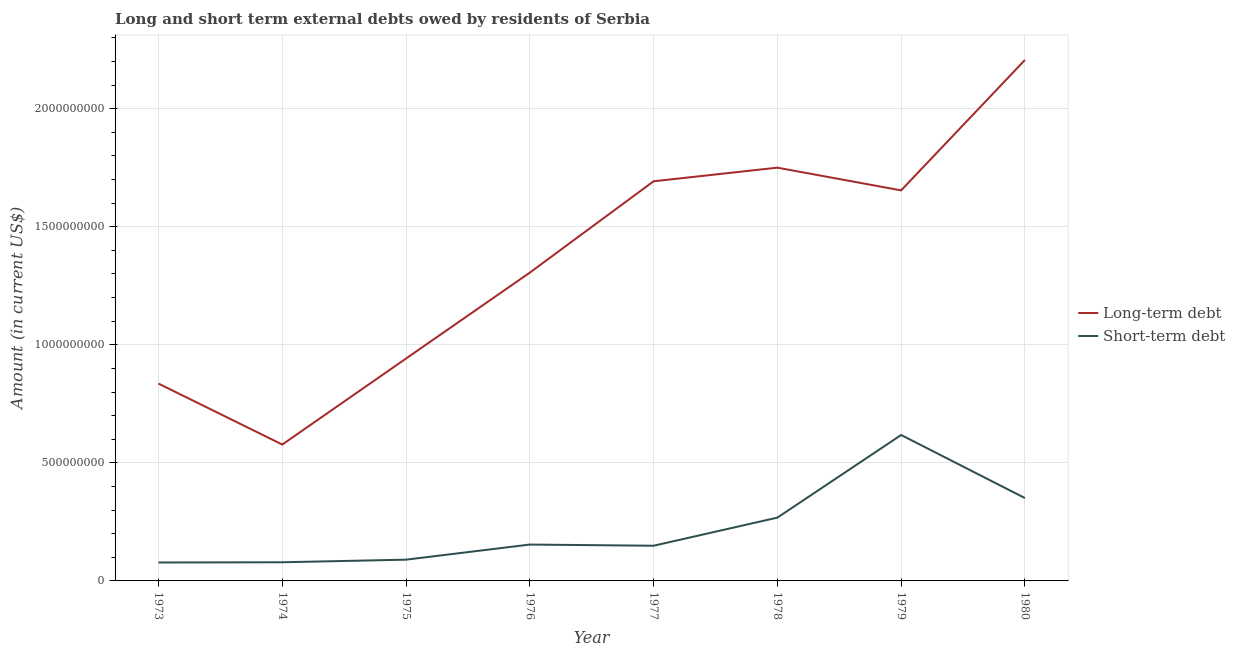Does the line corresponding to long-term debts owed by residents intersect with the line corresponding to short-term debts owed by residents?
Your answer should be very brief. No. What is the long-term debts owed by residents in 1979?
Keep it short and to the point. 1.65e+09. Across all years, what is the maximum short-term debts owed by residents?
Provide a short and direct response. 6.18e+08. Across all years, what is the minimum long-term debts owed by residents?
Offer a very short reply. 5.78e+08. What is the total short-term debts owed by residents in the graph?
Keep it short and to the point. 1.79e+09. What is the difference between the short-term debts owed by residents in 1974 and that in 1980?
Keep it short and to the point. -2.72e+08. What is the difference between the long-term debts owed by residents in 1980 and the short-term debts owed by residents in 1975?
Your answer should be very brief. 2.12e+09. What is the average short-term debts owed by residents per year?
Keep it short and to the point. 2.23e+08. In the year 1974, what is the difference between the short-term debts owed by residents and long-term debts owed by residents?
Your answer should be very brief. -4.99e+08. In how many years, is the long-term debts owed by residents greater than 1400000000 US$?
Your response must be concise. 4. What is the ratio of the short-term debts owed by residents in 1973 to that in 1979?
Make the answer very short. 0.13. What is the difference between the highest and the second highest long-term debts owed by residents?
Provide a succinct answer. 4.56e+08. What is the difference between the highest and the lowest long-term debts owed by residents?
Make the answer very short. 1.63e+09. Is the sum of the short-term debts owed by residents in 1976 and 1980 greater than the maximum long-term debts owed by residents across all years?
Ensure brevity in your answer.  No. Is the short-term debts owed by residents strictly less than the long-term debts owed by residents over the years?
Your answer should be compact. Yes. How many lines are there?
Ensure brevity in your answer.  2. Are the values on the major ticks of Y-axis written in scientific E-notation?
Offer a terse response. No. Where does the legend appear in the graph?
Your answer should be very brief. Center right. How are the legend labels stacked?
Ensure brevity in your answer.  Vertical. What is the title of the graph?
Make the answer very short. Long and short term external debts owed by residents of Serbia. What is the label or title of the X-axis?
Provide a short and direct response. Year. What is the label or title of the Y-axis?
Offer a very short reply. Amount (in current US$). What is the Amount (in current US$) of Long-term debt in 1973?
Keep it short and to the point. 8.36e+08. What is the Amount (in current US$) in Short-term debt in 1973?
Give a very brief answer. 7.80e+07. What is the Amount (in current US$) of Long-term debt in 1974?
Offer a terse response. 5.78e+08. What is the Amount (in current US$) of Short-term debt in 1974?
Provide a succinct answer. 7.90e+07. What is the Amount (in current US$) in Long-term debt in 1975?
Provide a short and direct response. 9.42e+08. What is the Amount (in current US$) in Short-term debt in 1975?
Make the answer very short. 9.00e+07. What is the Amount (in current US$) of Long-term debt in 1976?
Your answer should be very brief. 1.31e+09. What is the Amount (in current US$) of Short-term debt in 1976?
Provide a short and direct response. 1.54e+08. What is the Amount (in current US$) of Long-term debt in 1977?
Your answer should be compact. 1.69e+09. What is the Amount (in current US$) of Short-term debt in 1977?
Make the answer very short. 1.49e+08. What is the Amount (in current US$) of Long-term debt in 1978?
Offer a very short reply. 1.75e+09. What is the Amount (in current US$) of Short-term debt in 1978?
Provide a short and direct response. 2.68e+08. What is the Amount (in current US$) in Long-term debt in 1979?
Ensure brevity in your answer.  1.65e+09. What is the Amount (in current US$) in Short-term debt in 1979?
Make the answer very short. 6.18e+08. What is the Amount (in current US$) of Long-term debt in 1980?
Offer a very short reply. 2.21e+09. What is the Amount (in current US$) in Short-term debt in 1980?
Provide a short and direct response. 3.51e+08. Across all years, what is the maximum Amount (in current US$) of Long-term debt?
Make the answer very short. 2.21e+09. Across all years, what is the maximum Amount (in current US$) in Short-term debt?
Ensure brevity in your answer.  6.18e+08. Across all years, what is the minimum Amount (in current US$) of Long-term debt?
Provide a succinct answer. 5.78e+08. Across all years, what is the minimum Amount (in current US$) in Short-term debt?
Offer a very short reply. 7.80e+07. What is the total Amount (in current US$) of Long-term debt in the graph?
Your answer should be compact. 1.10e+1. What is the total Amount (in current US$) of Short-term debt in the graph?
Offer a very short reply. 1.79e+09. What is the difference between the Amount (in current US$) of Long-term debt in 1973 and that in 1974?
Provide a short and direct response. 2.58e+08. What is the difference between the Amount (in current US$) of Long-term debt in 1973 and that in 1975?
Keep it short and to the point. -1.06e+08. What is the difference between the Amount (in current US$) in Short-term debt in 1973 and that in 1975?
Your answer should be very brief. -1.20e+07. What is the difference between the Amount (in current US$) in Long-term debt in 1973 and that in 1976?
Provide a succinct answer. -4.70e+08. What is the difference between the Amount (in current US$) of Short-term debt in 1973 and that in 1976?
Your answer should be very brief. -7.60e+07. What is the difference between the Amount (in current US$) in Long-term debt in 1973 and that in 1977?
Provide a succinct answer. -8.57e+08. What is the difference between the Amount (in current US$) of Short-term debt in 1973 and that in 1977?
Make the answer very short. -7.10e+07. What is the difference between the Amount (in current US$) of Long-term debt in 1973 and that in 1978?
Ensure brevity in your answer.  -9.14e+08. What is the difference between the Amount (in current US$) of Short-term debt in 1973 and that in 1978?
Offer a terse response. -1.90e+08. What is the difference between the Amount (in current US$) in Long-term debt in 1973 and that in 1979?
Make the answer very short. -8.18e+08. What is the difference between the Amount (in current US$) in Short-term debt in 1973 and that in 1979?
Offer a very short reply. -5.40e+08. What is the difference between the Amount (in current US$) of Long-term debt in 1973 and that in 1980?
Keep it short and to the point. -1.37e+09. What is the difference between the Amount (in current US$) in Short-term debt in 1973 and that in 1980?
Offer a very short reply. -2.73e+08. What is the difference between the Amount (in current US$) of Long-term debt in 1974 and that in 1975?
Ensure brevity in your answer.  -3.64e+08. What is the difference between the Amount (in current US$) in Short-term debt in 1974 and that in 1975?
Your response must be concise. -1.10e+07. What is the difference between the Amount (in current US$) in Long-term debt in 1974 and that in 1976?
Your response must be concise. -7.28e+08. What is the difference between the Amount (in current US$) in Short-term debt in 1974 and that in 1976?
Provide a succinct answer. -7.50e+07. What is the difference between the Amount (in current US$) of Long-term debt in 1974 and that in 1977?
Provide a succinct answer. -1.11e+09. What is the difference between the Amount (in current US$) in Short-term debt in 1974 and that in 1977?
Offer a very short reply. -7.00e+07. What is the difference between the Amount (in current US$) of Long-term debt in 1974 and that in 1978?
Your answer should be very brief. -1.17e+09. What is the difference between the Amount (in current US$) of Short-term debt in 1974 and that in 1978?
Offer a terse response. -1.89e+08. What is the difference between the Amount (in current US$) in Long-term debt in 1974 and that in 1979?
Your answer should be compact. -1.08e+09. What is the difference between the Amount (in current US$) in Short-term debt in 1974 and that in 1979?
Your answer should be very brief. -5.39e+08. What is the difference between the Amount (in current US$) of Long-term debt in 1974 and that in 1980?
Make the answer very short. -1.63e+09. What is the difference between the Amount (in current US$) in Short-term debt in 1974 and that in 1980?
Offer a very short reply. -2.72e+08. What is the difference between the Amount (in current US$) of Long-term debt in 1975 and that in 1976?
Keep it short and to the point. -3.64e+08. What is the difference between the Amount (in current US$) of Short-term debt in 1975 and that in 1976?
Offer a terse response. -6.40e+07. What is the difference between the Amount (in current US$) of Long-term debt in 1975 and that in 1977?
Offer a very short reply. -7.51e+08. What is the difference between the Amount (in current US$) in Short-term debt in 1975 and that in 1977?
Provide a short and direct response. -5.90e+07. What is the difference between the Amount (in current US$) of Long-term debt in 1975 and that in 1978?
Provide a short and direct response. -8.08e+08. What is the difference between the Amount (in current US$) in Short-term debt in 1975 and that in 1978?
Provide a succinct answer. -1.78e+08. What is the difference between the Amount (in current US$) of Long-term debt in 1975 and that in 1979?
Your answer should be very brief. -7.12e+08. What is the difference between the Amount (in current US$) of Short-term debt in 1975 and that in 1979?
Offer a very short reply. -5.28e+08. What is the difference between the Amount (in current US$) of Long-term debt in 1975 and that in 1980?
Ensure brevity in your answer.  -1.26e+09. What is the difference between the Amount (in current US$) in Short-term debt in 1975 and that in 1980?
Your response must be concise. -2.61e+08. What is the difference between the Amount (in current US$) in Long-term debt in 1976 and that in 1977?
Your answer should be very brief. -3.87e+08. What is the difference between the Amount (in current US$) of Short-term debt in 1976 and that in 1977?
Offer a terse response. 5.00e+06. What is the difference between the Amount (in current US$) of Long-term debt in 1976 and that in 1978?
Give a very brief answer. -4.45e+08. What is the difference between the Amount (in current US$) of Short-term debt in 1976 and that in 1978?
Offer a terse response. -1.14e+08. What is the difference between the Amount (in current US$) of Long-term debt in 1976 and that in 1979?
Your answer should be compact. -3.48e+08. What is the difference between the Amount (in current US$) of Short-term debt in 1976 and that in 1979?
Make the answer very short. -4.64e+08. What is the difference between the Amount (in current US$) of Long-term debt in 1976 and that in 1980?
Give a very brief answer. -9.00e+08. What is the difference between the Amount (in current US$) in Short-term debt in 1976 and that in 1980?
Your answer should be compact. -1.97e+08. What is the difference between the Amount (in current US$) of Long-term debt in 1977 and that in 1978?
Provide a short and direct response. -5.77e+07. What is the difference between the Amount (in current US$) of Short-term debt in 1977 and that in 1978?
Give a very brief answer. -1.19e+08. What is the difference between the Amount (in current US$) of Long-term debt in 1977 and that in 1979?
Provide a succinct answer. 3.85e+07. What is the difference between the Amount (in current US$) in Short-term debt in 1977 and that in 1979?
Give a very brief answer. -4.69e+08. What is the difference between the Amount (in current US$) of Long-term debt in 1977 and that in 1980?
Offer a terse response. -5.14e+08. What is the difference between the Amount (in current US$) in Short-term debt in 1977 and that in 1980?
Your answer should be compact. -2.02e+08. What is the difference between the Amount (in current US$) in Long-term debt in 1978 and that in 1979?
Offer a very short reply. 9.62e+07. What is the difference between the Amount (in current US$) in Short-term debt in 1978 and that in 1979?
Offer a very short reply. -3.50e+08. What is the difference between the Amount (in current US$) in Long-term debt in 1978 and that in 1980?
Your answer should be compact. -4.56e+08. What is the difference between the Amount (in current US$) in Short-term debt in 1978 and that in 1980?
Offer a very short reply. -8.30e+07. What is the difference between the Amount (in current US$) of Long-term debt in 1979 and that in 1980?
Your answer should be very brief. -5.52e+08. What is the difference between the Amount (in current US$) in Short-term debt in 1979 and that in 1980?
Your response must be concise. 2.67e+08. What is the difference between the Amount (in current US$) of Long-term debt in 1973 and the Amount (in current US$) of Short-term debt in 1974?
Give a very brief answer. 7.57e+08. What is the difference between the Amount (in current US$) of Long-term debt in 1973 and the Amount (in current US$) of Short-term debt in 1975?
Offer a terse response. 7.46e+08. What is the difference between the Amount (in current US$) in Long-term debt in 1973 and the Amount (in current US$) in Short-term debt in 1976?
Your answer should be very brief. 6.82e+08. What is the difference between the Amount (in current US$) of Long-term debt in 1973 and the Amount (in current US$) of Short-term debt in 1977?
Keep it short and to the point. 6.87e+08. What is the difference between the Amount (in current US$) in Long-term debt in 1973 and the Amount (in current US$) in Short-term debt in 1978?
Your answer should be very brief. 5.68e+08. What is the difference between the Amount (in current US$) in Long-term debt in 1973 and the Amount (in current US$) in Short-term debt in 1979?
Provide a short and direct response. 2.18e+08. What is the difference between the Amount (in current US$) in Long-term debt in 1973 and the Amount (in current US$) in Short-term debt in 1980?
Give a very brief answer. 4.85e+08. What is the difference between the Amount (in current US$) in Long-term debt in 1974 and the Amount (in current US$) in Short-term debt in 1975?
Keep it short and to the point. 4.88e+08. What is the difference between the Amount (in current US$) in Long-term debt in 1974 and the Amount (in current US$) in Short-term debt in 1976?
Keep it short and to the point. 4.24e+08. What is the difference between the Amount (in current US$) of Long-term debt in 1974 and the Amount (in current US$) of Short-term debt in 1977?
Your response must be concise. 4.29e+08. What is the difference between the Amount (in current US$) of Long-term debt in 1974 and the Amount (in current US$) of Short-term debt in 1978?
Your response must be concise. 3.10e+08. What is the difference between the Amount (in current US$) of Long-term debt in 1974 and the Amount (in current US$) of Short-term debt in 1979?
Your answer should be compact. -4.04e+07. What is the difference between the Amount (in current US$) of Long-term debt in 1974 and the Amount (in current US$) of Short-term debt in 1980?
Your answer should be very brief. 2.27e+08. What is the difference between the Amount (in current US$) in Long-term debt in 1975 and the Amount (in current US$) in Short-term debt in 1976?
Ensure brevity in your answer.  7.88e+08. What is the difference between the Amount (in current US$) of Long-term debt in 1975 and the Amount (in current US$) of Short-term debt in 1977?
Make the answer very short. 7.93e+08. What is the difference between the Amount (in current US$) of Long-term debt in 1975 and the Amount (in current US$) of Short-term debt in 1978?
Make the answer very short. 6.74e+08. What is the difference between the Amount (in current US$) in Long-term debt in 1975 and the Amount (in current US$) in Short-term debt in 1979?
Provide a short and direct response. 3.24e+08. What is the difference between the Amount (in current US$) of Long-term debt in 1975 and the Amount (in current US$) of Short-term debt in 1980?
Your response must be concise. 5.91e+08. What is the difference between the Amount (in current US$) in Long-term debt in 1976 and the Amount (in current US$) in Short-term debt in 1977?
Provide a succinct answer. 1.16e+09. What is the difference between the Amount (in current US$) of Long-term debt in 1976 and the Amount (in current US$) of Short-term debt in 1978?
Ensure brevity in your answer.  1.04e+09. What is the difference between the Amount (in current US$) in Long-term debt in 1976 and the Amount (in current US$) in Short-term debt in 1979?
Make the answer very short. 6.88e+08. What is the difference between the Amount (in current US$) of Long-term debt in 1976 and the Amount (in current US$) of Short-term debt in 1980?
Keep it short and to the point. 9.55e+08. What is the difference between the Amount (in current US$) in Long-term debt in 1977 and the Amount (in current US$) in Short-term debt in 1978?
Make the answer very short. 1.42e+09. What is the difference between the Amount (in current US$) in Long-term debt in 1977 and the Amount (in current US$) in Short-term debt in 1979?
Your answer should be compact. 1.07e+09. What is the difference between the Amount (in current US$) in Long-term debt in 1977 and the Amount (in current US$) in Short-term debt in 1980?
Your answer should be compact. 1.34e+09. What is the difference between the Amount (in current US$) of Long-term debt in 1978 and the Amount (in current US$) of Short-term debt in 1979?
Make the answer very short. 1.13e+09. What is the difference between the Amount (in current US$) of Long-term debt in 1978 and the Amount (in current US$) of Short-term debt in 1980?
Make the answer very short. 1.40e+09. What is the difference between the Amount (in current US$) in Long-term debt in 1979 and the Amount (in current US$) in Short-term debt in 1980?
Keep it short and to the point. 1.30e+09. What is the average Amount (in current US$) in Long-term debt per year?
Offer a terse response. 1.37e+09. What is the average Amount (in current US$) of Short-term debt per year?
Give a very brief answer. 2.23e+08. In the year 1973, what is the difference between the Amount (in current US$) in Long-term debt and Amount (in current US$) in Short-term debt?
Offer a very short reply. 7.58e+08. In the year 1974, what is the difference between the Amount (in current US$) in Long-term debt and Amount (in current US$) in Short-term debt?
Provide a short and direct response. 4.99e+08. In the year 1975, what is the difference between the Amount (in current US$) of Long-term debt and Amount (in current US$) of Short-term debt?
Your answer should be compact. 8.52e+08. In the year 1976, what is the difference between the Amount (in current US$) of Long-term debt and Amount (in current US$) of Short-term debt?
Your response must be concise. 1.15e+09. In the year 1977, what is the difference between the Amount (in current US$) in Long-term debt and Amount (in current US$) in Short-term debt?
Ensure brevity in your answer.  1.54e+09. In the year 1978, what is the difference between the Amount (in current US$) of Long-term debt and Amount (in current US$) of Short-term debt?
Your answer should be compact. 1.48e+09. In the year 1979, what is the difference between the Amount (in current US$) in Long-term debt and Amount (in current US$) in Short-term debt?
Your answer should be compact. 1.04e+09. In the year 1980, what is the difference between the Amount (in current US$) in Long-term debt and Amount (in current US$) in Short-term debt?
Provide a succinct answer. 1.86e+09. What is the ratio of the Amount (in current US$) of Long-term debt in 1973 to that in 1974?
Make the answer very short. 1.45. What is the ratio of the Amount (in current US$) of Short-term debt in 1973 to that in 1974?
Make the answer very short. 0.99. What is the ratio of the Amount (in current US$) of Long-term debt in 1973 to that in 1975?
Offer a terse response. 0.89. What is the ratio of the Amount (in current US$) of Short-term debt in 1973 to that in 1975?
Your response must be concise. 0.87. What is the ratio of the Amount (in current US$) of Long-term debt in 1973 to that in 1976?
Your answer should be very brief. 0.64. What is the ratio of the Amount (in current US$) of Short-term debt in 1973 to that in 1976?
Offer a very short reply. 0.51. What is the ratio of the Amount (in current US$) of Long-term debt in 1973 to that in 1977?
Give a very brief answer. 0.49. What is the ratio of the Amount (in current US$) in Short-term debt in 1973 to that in 1977?
Your answer should be compact. 0.52. What is the ratio of the Amount (in current US$) of Long-term debt in 1973 to that in 1978?
Keep it short and to the point. 0.48. What is the ratio of the Amount (in current US$) of Short-term debt in 1973 to that in 1978?
Offer a very short reply. 0.29. What is the ratio of the Amount (in current US$) in Long-term debt in 1973 to that in 1979?
Provide a succinct answer. 0.51. What is the ratio of the Amount (in current US$) in Short-term debt in 1973 to that in 1979?
Provide a succinct answer. 0.13. What is the ratio of the Amount (in current US$) in Long-term debt in 1973 to that in 1980?
Provide a succinct answer. 0.38. What is the ratio of the Amount (in current US$) in Short-term debt in 1973 to that in 1980?
Give a very brief answer. 0.22. What is the ratio of the Amount (in current US$) of Long-term debt in 1974 to that in 1975?
Your answer should be very brief. 0.61. What is the ratio of the Amount (in current US$) in Short-term debt in 1974 to that in 1975?
Provide a short and direct response. 0.88. What is the ratio of the Amount (in current US$) of Long-term debt in 1974 to that in 1976?
Give a very brief answer. 0.44. What is the ratio of the Amount (in current US$) in Short-term debt in 1974 to that in 1976?
Your response must be concise. 0.51. What is the ratio of the Amount (in current US$) of Long-term debt in 1974 to that in 1977?
Make the answer very short. 0.34. What is the ratio of the Amount (in current US$) in Short-term debt in 1974 to that in 1977?
Offer a very short reply. 0.53. What is the ratio of the Amount (in current US$) of Long-term debt in 1974 to that in 1978?
Offer a terse response. 0.33. What is the ratio of the Amount (in current US$) in Short-term debt in 1974 to that in 1978?
Make the answer very short. 0.29. What is the ratio of the Amount (in current US$) of Long-term debt in 1974 to that in 1979?
Give a very brief answer. 0.35. What is the ratio of the Amount (in current US$) of Short-term debt in 1974 to that in 1979?
Make the answer very short. 0.13. What is the ratio of the Amount (in current US$) of Long-term debt in 1974 to that in 1980?
Offer a terse response. 0.26. What is the ratio of the Amount (in current US$) of Short-term debt in 1974 to that in 1980?
Give a very brief answer. 0.23. What is the ratio of the Amount (in current US$) in Long-term debt in 1975 to that in 1976?
Offer a terse response. 0.72. What is the ratio of the Amount (in current US$) of Short-term debt in 1975 to that in 1976?
Offer a very short reply. 0.58. What is the ratio of the Amount (in current US$) of Long-term debt in 1975 to that in 1977?
Make the answer very short. 0.56. What is the ratio of the Amount (in current US$) in Short-term debt in 1975 to that in 1977?
Provide a short and direct response. 0.6. What is the ratio of the Amount (in current US$) in Long-term debt in 1975 to that in 1978?
Your response must be concise. 0.54. What is the ratio of the Amount (in current US$) of Short-term debt in 1975 to that in 1978?
Your response must be concise. 0.34. What is the ratio of the Amount (in current US$) in Long-term debt in 1975 to that in 1979?
Ensure brevity in your answer.  0.57. What is the ratio of the Amount (in current US$) of Short-term debt in 1975 to that in 1979?
Give a very brief answer. 0.15. What is the ratio of the Amount (in current US$) of Long-term debt in 1975 to that in 1980?
Your response must be concise. 0.43. What is the ratio of the Amount (in current US$) of Short-term debt in 1975 to that in 1980?
Provide a succinct answer. 0.26. What is the ratio of the Amount (in current US$) in Long-term debt in 1976 to that in 1977?
Make the answer very short. 0.77. What is the ratio of the Amount (in current US$) of Short-term debt in 1976 to that in 1977?
Offer a terse response. 1.03. What is the ratio of the Amount (in current US$) in Long-term debt in 1976 to that in 1978?
Give a very brief answer. 0.75. What is the ratio of the Amount (in current US$) of Short-term debt in 1976 to that in 1978?
Ensure brevity in your answer.  0.57. What is the ratio of the Amount (in current US$) in Long-term debt in 1976 to that in 1979?
Your answer should be very brief. 0.79. What is the ratio of the Amount (in current US$) in Short-term debt in 1976 to that in 1979?
Your answer should be compact. 0.25. What is the ratio of the Amount (in current US$) of Long-term debt in 1976 to that in 1980?
Your response must be concise. 0.59. What is the ratio of the Amount (in current US$) of Short-term debt in 1976 to that in 1980?
Offer a very short reply. 0.44. What is the ratio of the Amount (in current US$) of Long-term debt in 1977 to that in 1978?
Your answer should be very brief. 0.97. What is the ratio of the Amount (in current US$) in Short-term debt in 1977 to that in 1978?
Give a very brief answer. 0.56. What is the ratio of the Amount (in current US$) in Long-term debt in 1977 to that in 1979?
Provide a short and direct response. 1.02. What is the ratio of the Amount (in current US$) in Short-term debt in 1977 to that in 1979?
Your response must be concise. 0.24. What is the ratio of the Amount (in current US$) of Long-term debt in 1977 to that in 1980?
Make the answer very short. 0.77. What is the ratio of the Amount (in current US$) in Short-term debt in 1977 to that in 1980?
Ensure brevity in your answer.  0.42. What is the ratio of the Amount (in current US$) in Long-term debt in 1978 to that in 1979?
Your answer should be very brief. 1.06. What is the ratio of the Amount (in current US$) in Short-term debt in 1978 to that in 1979?
Make the answer very short. 0.43. What is the ratio of the Amount (in current US$) of Long-term debt in 1978 to that in 1980?
Ensure brevity in your answer.  0.79. What is the ratio of the Amount (in current US$) in Short-term debt in 1978 to that in 1980?
Give a very brief answer. 0.76. What is the ratio of the Amount (in current US$) in Long-term debt in 1979 to that in 1980?
Make the answer very short. 0.75. What is the ratio of the Amount (in current US$) of Short-term debt in 1979 to that in 1980?
Make the answer very short. 1.76. What is the difference between the highest and the second highest Amount (in current US$) of Long-term debt?
Your answer should be very brief. 4.56e+08. What is the difference between the highest and the second highest Amount (in current US$) in Short-term debt?
Keep it short and to the point. 2.67e+08. What is the difference between the highest and the lowest Amount (in current US$) in Long-term debt?
Your answer should be compact. 1.63e+09. What is the difference between the highest and the lowest Amount (in current US$) of Short-term debt?
Offer a terse response. 5.40e+08. 